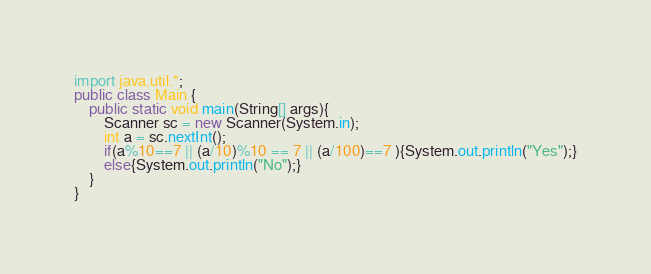<code> <loc_0><loc_0><loc_500><loc_500><_Java_>import java.util.*;
public class Main {
	public static void main(String[] args){
		Scanner sc = new Scanner(System.in);
		int a = sc.nextInt();
		if(a%10==7 || (a/10)%10 == 7 || (a/100)==7 ){System.out.println("Yes");}
		else{System.out.println("No");}
	}
}
</code> 